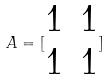<formula> <loc_0><loc_0><loc_500><loc_500>A = [ \begin{matrix} 1 & 1 \\ 1 & 1 \end{matrix} ]</formula> 